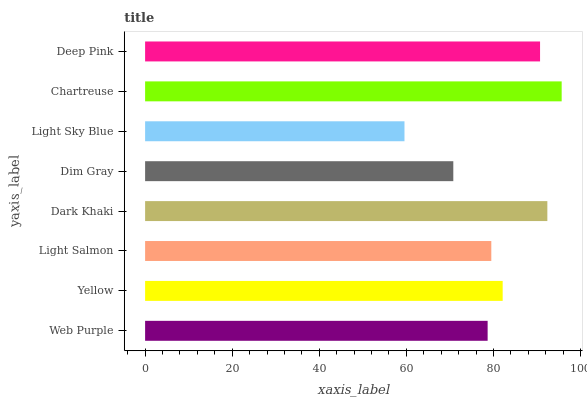Is Light Sky Blue the minimum?
Answer yes or no. Yes. Is Chartreuse the maximum?
Answer yes or no. Yes. Is Yellow the minimum?
Answer yes or no. No. Is Yellow the maximum?
Answer yes or no. No. Is Yellow greater than Web Purple?
Answer yes or no. Yes. Is Web Purple less than Yellow?
Answer yes or no. Yes. Is Web Purple greater than Yellow?
Answer yes or no. No. Is Yellow less than Web Purple?
Answer yes or no. No. Is Yellow the high median?
Answer yes or no. Yes. Is Light Salmon the low median?
Answer yes or no. Yes. Is Light Sky Blue the high median?
Answer yes or no. No. Is Chartreuse the low median?
Answer yes or no. No. 